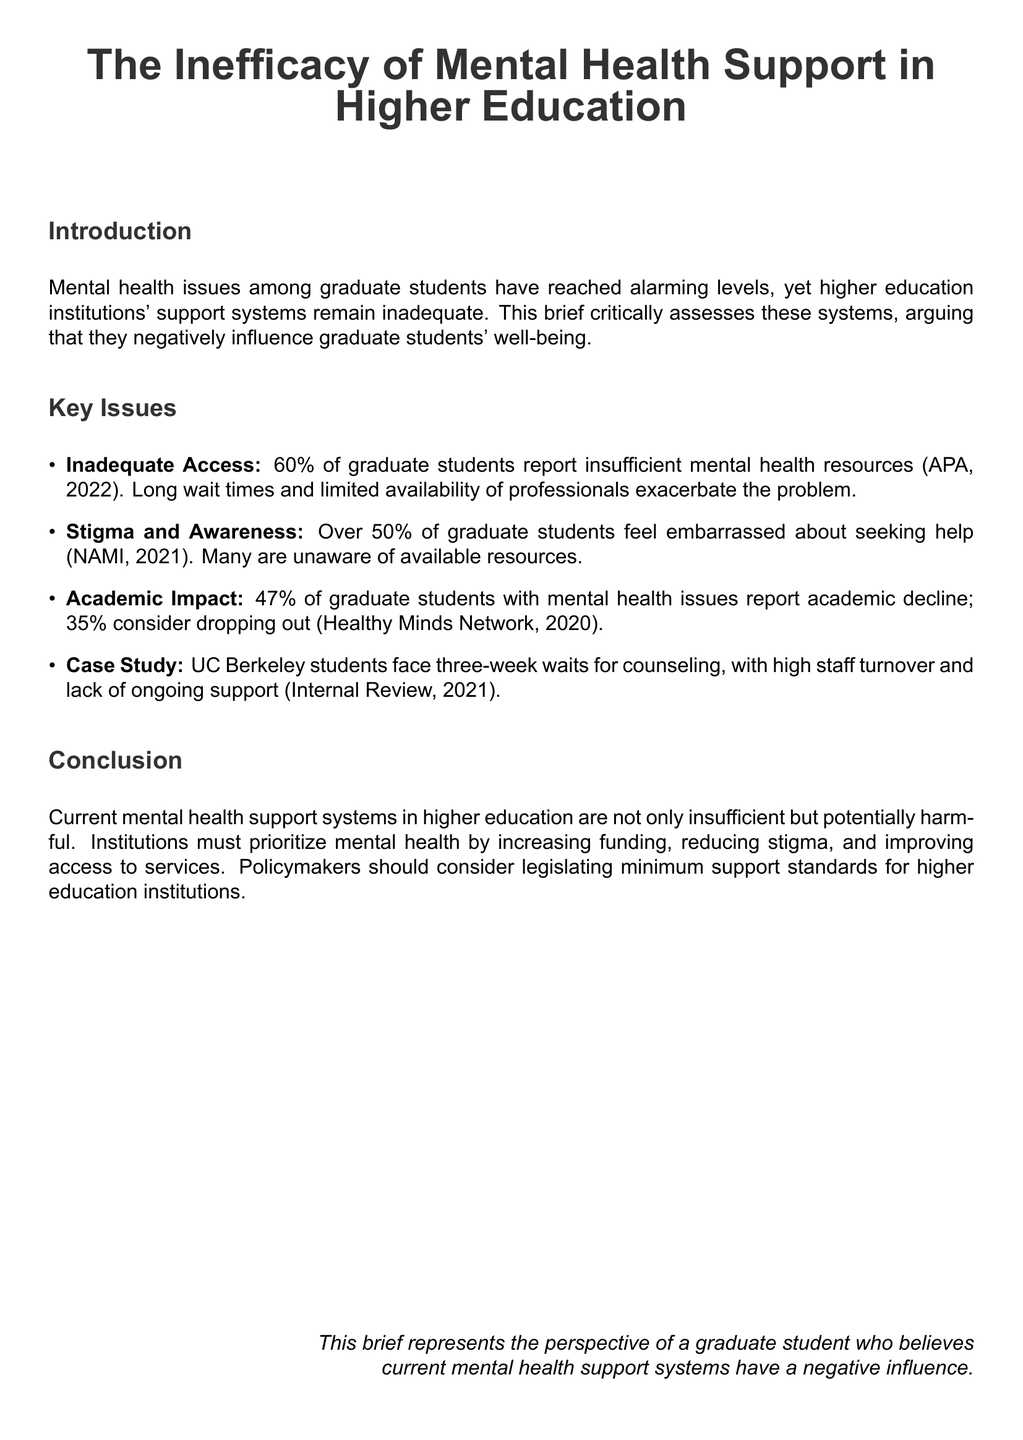What percentage of graduate students report insufficient mental health resources? The document states that 60% of graduate students report insufficient mental health resources.
Answer: 60% What is the main reason for graduate students feeling embarrassed about seeking help? Over 50% of graduate students feel embarrassed about seeking help as mentioned in the document.
Answer: Stigma What is the percentage of graduate students with mental health issues who report academic decline? The brief mentions that 47% of graduate students with mental health issues report academic decline.
Answer: 47% How long do UC Berkeley students wait for counseling? The document indicates that UC Berkeley students face three-week waits for counseling.
Answer: Three weeks What does the brief recommend policymakers should consider? The brief advises that policymakers should consider legislating minimum support standards for higher education institutions.
Answer: Legislating minimum support standards What does the title of the document state about mental health support? The title explicitly states the ineffectiveness of mental health support in higher education.
Answer: The Inefficacy of Mental Health Support What should institutions prioritize according to the conclusion? The conclusion suggests that institutions must prioritize mental health.
Answer: Mental health What year did the Healthy Minds Network report on academic decline among graduate students? The document cites the Healthy Minds Network report from the year 2020.
Answer: 2020 